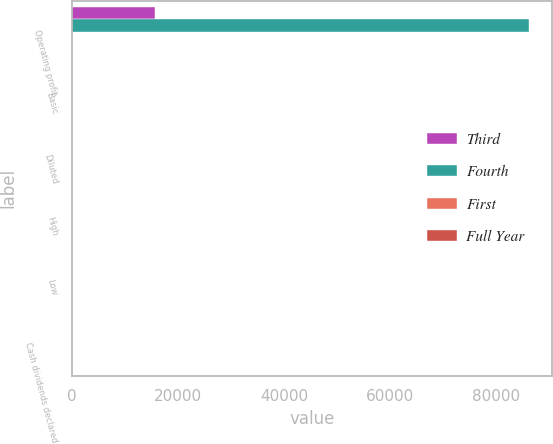Convert chart to OTSL. <chart><loc_0><loc_0><loc_500><loc_500><stacked_bar_chart><ecel><fcel>Operating profit<fcel>Basic<fcel>Diluted<fcel>High<fcel>Low<fcel>Cash dividends declared<nl><fcel>Third<fcel>15726<fcel>0.02<fcel>0.02<fcel>37.7<fcel>31.51<fcel>0.36<nl><fcel>Fourth<fcel>86282<fcel>0.33<fcel>0.33<fcel>37.55<fcel>32<fcel>0.36<nl><fcel>First<fcel>1.25<fcel>1.26<fcel>1.24<fcel>39.98<fcel>32.29<fcel>0.36<nl><fcel>Full Year<fcel>1.25<fcel>1<fcel>0.99<fcel>39.96<fcel>34.91<fcel>0.36<nl></chart> 